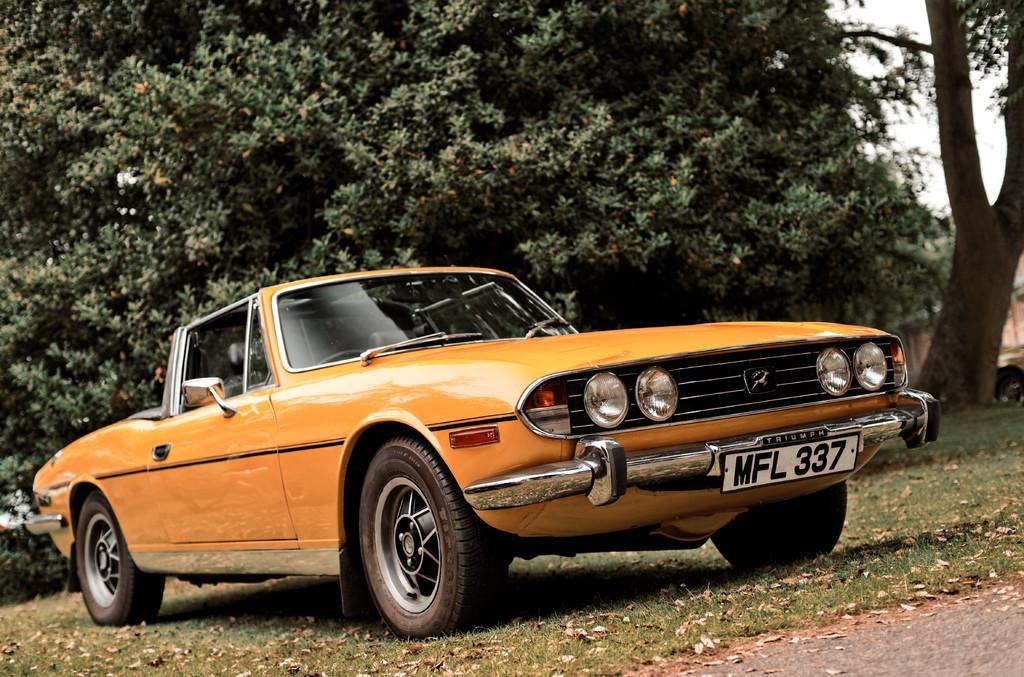In one or two sentences, can you explain what this image depicts? In this image I can see the car which is in orange color. I can see the number plate to the car. It is on the ground. In the background I can see many trees and the sky. 